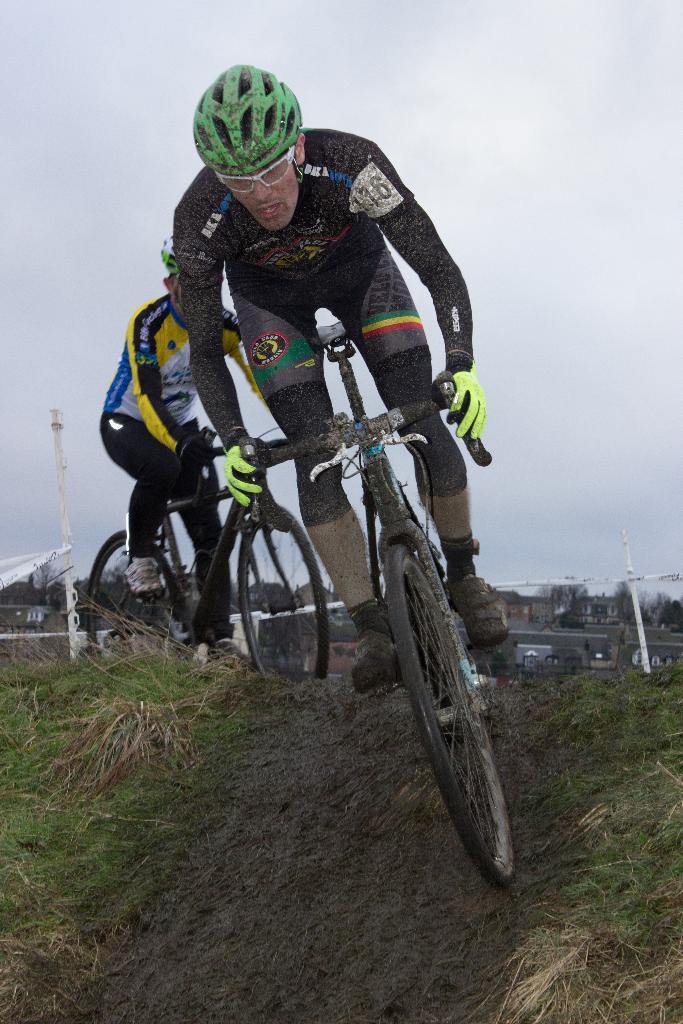Could you give a brief overview of what you see in this image? In this image we can see there are two people riding bicycles and the background is the sky. 